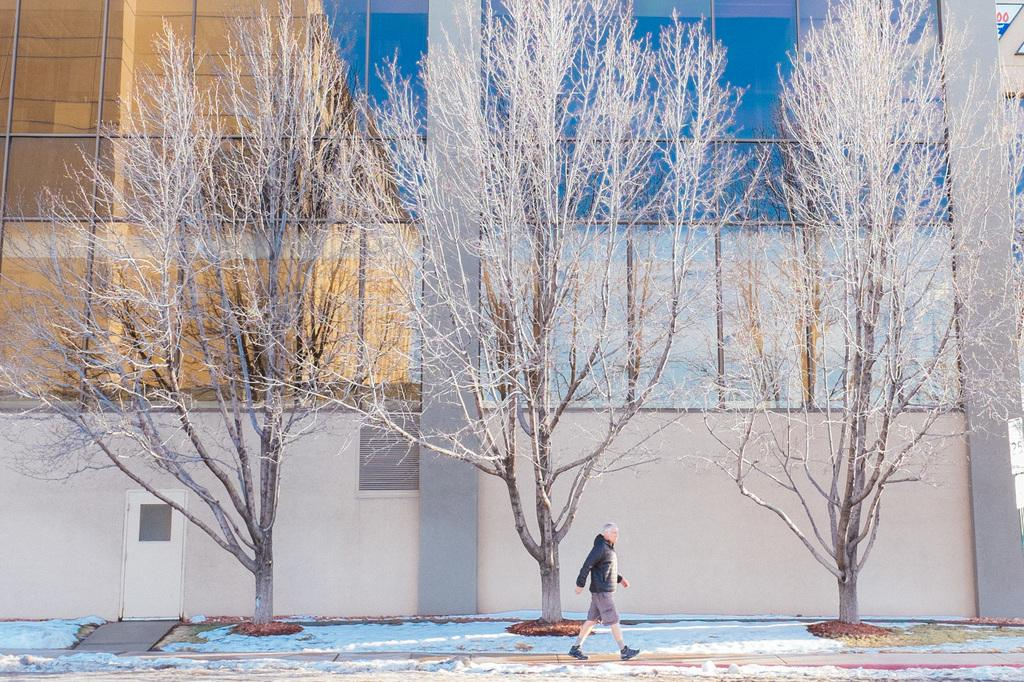What can be seen in the image that people might walk on? There is a path in the image that people might walk on. Can you describe the person in the image? A person is walking beside the path in the image. What type of vegetation is present in the image? There are dried trees in the image. What is visible in the background of the image? There is a wall in the background of the image, and behind the wall, there is a glass building. What type of comfort can be seen in the image? There is no specific comfort item present in the image. Can you describe the person's finger in the image? There is no visible finger or hand of the person in the image. 